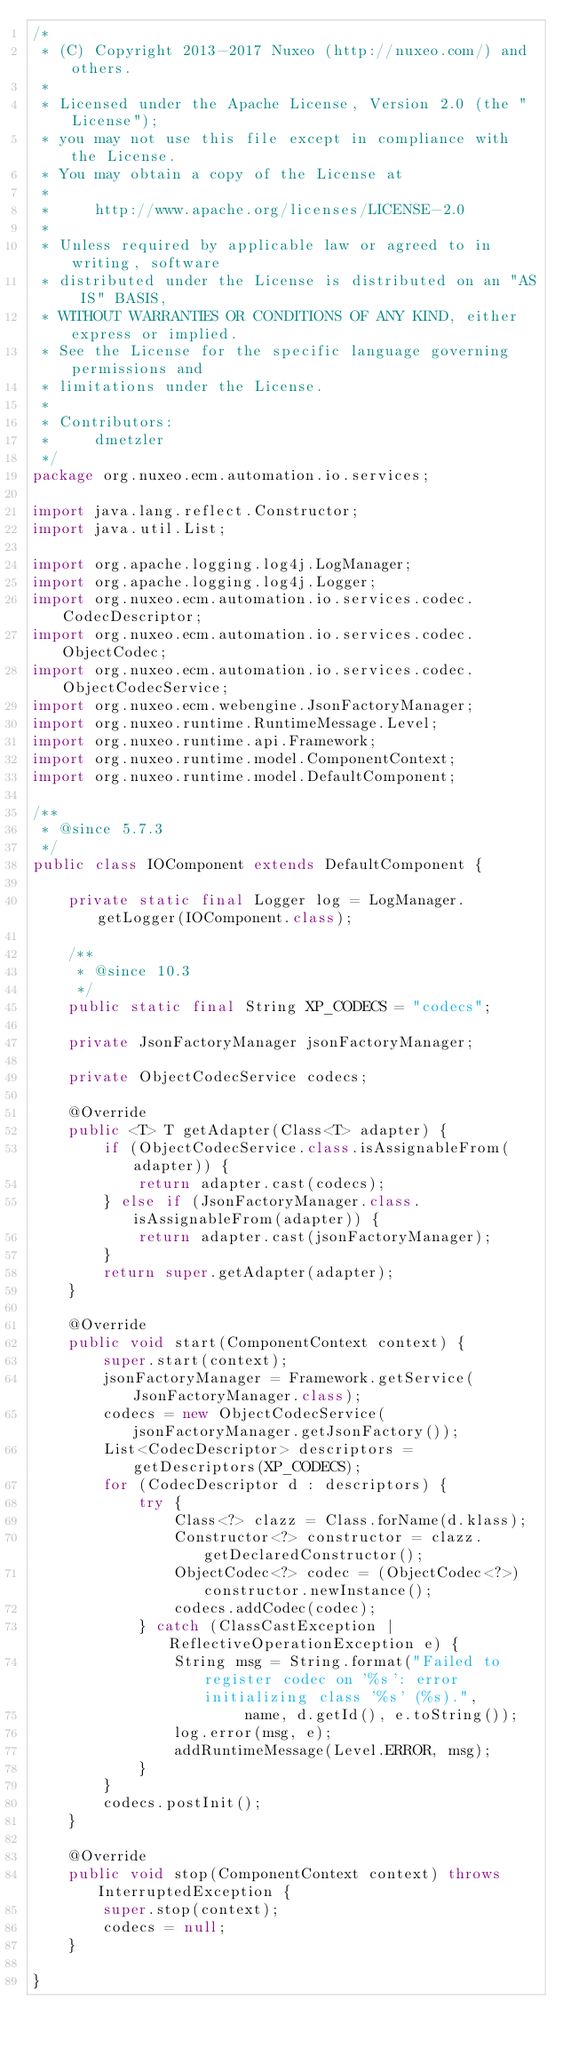Convert code to text. <code><loc_0><loc_0><loc_500><loc_500><_Java_>/*
 * (C) Copyright 2013-2017 Nuxeo (http://nuxeo.com/) and others.
 *
 * Licensed under the Apache License, Version 2.0 (the "License");
 * you may not use this file except in compliance with the License.
 * You may obtain a copy of the License at
 *
 *     http://www.apache.org/licenses/LICENSE-2.0
 *
 * Unless required by applicable law or agreed to in writing, software
 * distributed under the License is distributed on an "AS IS" BASIS,
 * WITHOUT WARRANTIES OR CONDITIONS OF ANY KIND, either express or implied.
 * See the License for the specific language governing permissions and
 * limitations under the License.
 *
 * Contributors:
 *     dmetzler
 */
package org.nuxeo.ecm.automation.io.services;

import java.lang.reflect.Constructor;
import java.util.List;

import org.apache.logging.log4j.LogManager;
import org.apache.logging.log4j.Logger;
import org.nuxeo.ecm.automation.io.services.codec.CodecDescriptor;
import org.nuxeo.ecm.automation.io.services.codec.ObjectCodec;
import org.nuxeo.ecm.automation.io.services.codec.ObjectCodecService;
import org.nuxeo.ecm.webengine.JsonFactoryManager;
import org.nuxeo.runtime.RuntimeMessage.Level;
import org.nuxeo.runtime.api.Framework;
import org.nuxeo.runtime.model.ComponentContext;
import org.nuxeo.runtime.model.DefaultComponent;

/**
 * @since 5.7.3
 */
public class IOComponent extends DefaultComponent {

    private static final Logger log = LogManager.getLogger(IOComponent.class);

    /**
     * @since 10.3
     */
    public static final String XP_CODECS = "codecs";

    private JsonFactoryManager jsonFactoryManager;

    private ObjectCodecService codecs;

    @Override
    public <T> T getAdapter(Class<T> adapter) {
        if (ObjectCodecService.class.isAssignableFrom(adapter)) {
            return adapter.cast(codecs);
        } else if (JsonFactoryManager.class.isAssignableFrom(adapter)) {
            return adapter.cast(jsonFactoryManager);
        }
        return super.getAdapter(adapter);
    }

    @Override
    public void start(ComponentContext context) {
        super.start(context);
        jsonFactoryManager = Framework.getService(JsonFactoryManager.class);
        codecs = new ObjectCodecService(jsonFactoryManager.getJsonFactory());
        List<CodecDescriptor> descriptors = getDescriptors(XP_CODECS);
        for (CodecDescriptor d : descriptors) {
            try {
                Class<?> clazz = Class.forName(d.klass);
                Constructor<?> constructor = clazz.getDeclaredConstructor();
                ObjectCodec<?> codec = (ObjectCodec<?>) constructor.newInstance();
                codecs.addCodec(codec);
            } catch (ClassCastException | ReflectiveOperationException e) {
                String msg = String.format("Failed to register codec on '%s': error initializing class '%s' (%s).",
                        name, d.getId(), e.toString());
                log.error(msg, e);
                addRuntimeMessage(Level.ERROR, msg);
            }
        }
        codecs.postInit();
    }

    @Override
    public void stop(ComponentContext context) throws InterruptedException {
        super.stop(context);
        codecs = null;
    }

}
</code> 